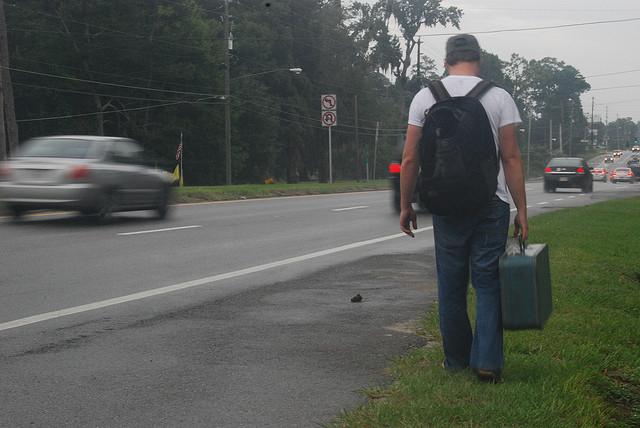What is the color of the car?
Answer briefly. Silver. Which hand carries a suitcase?
Answer briefly. Right. Why isn't he on a sidewalk?
Short answer required. There isn't one. Is the man wearing a sweater?
Write a very short answer. No. 